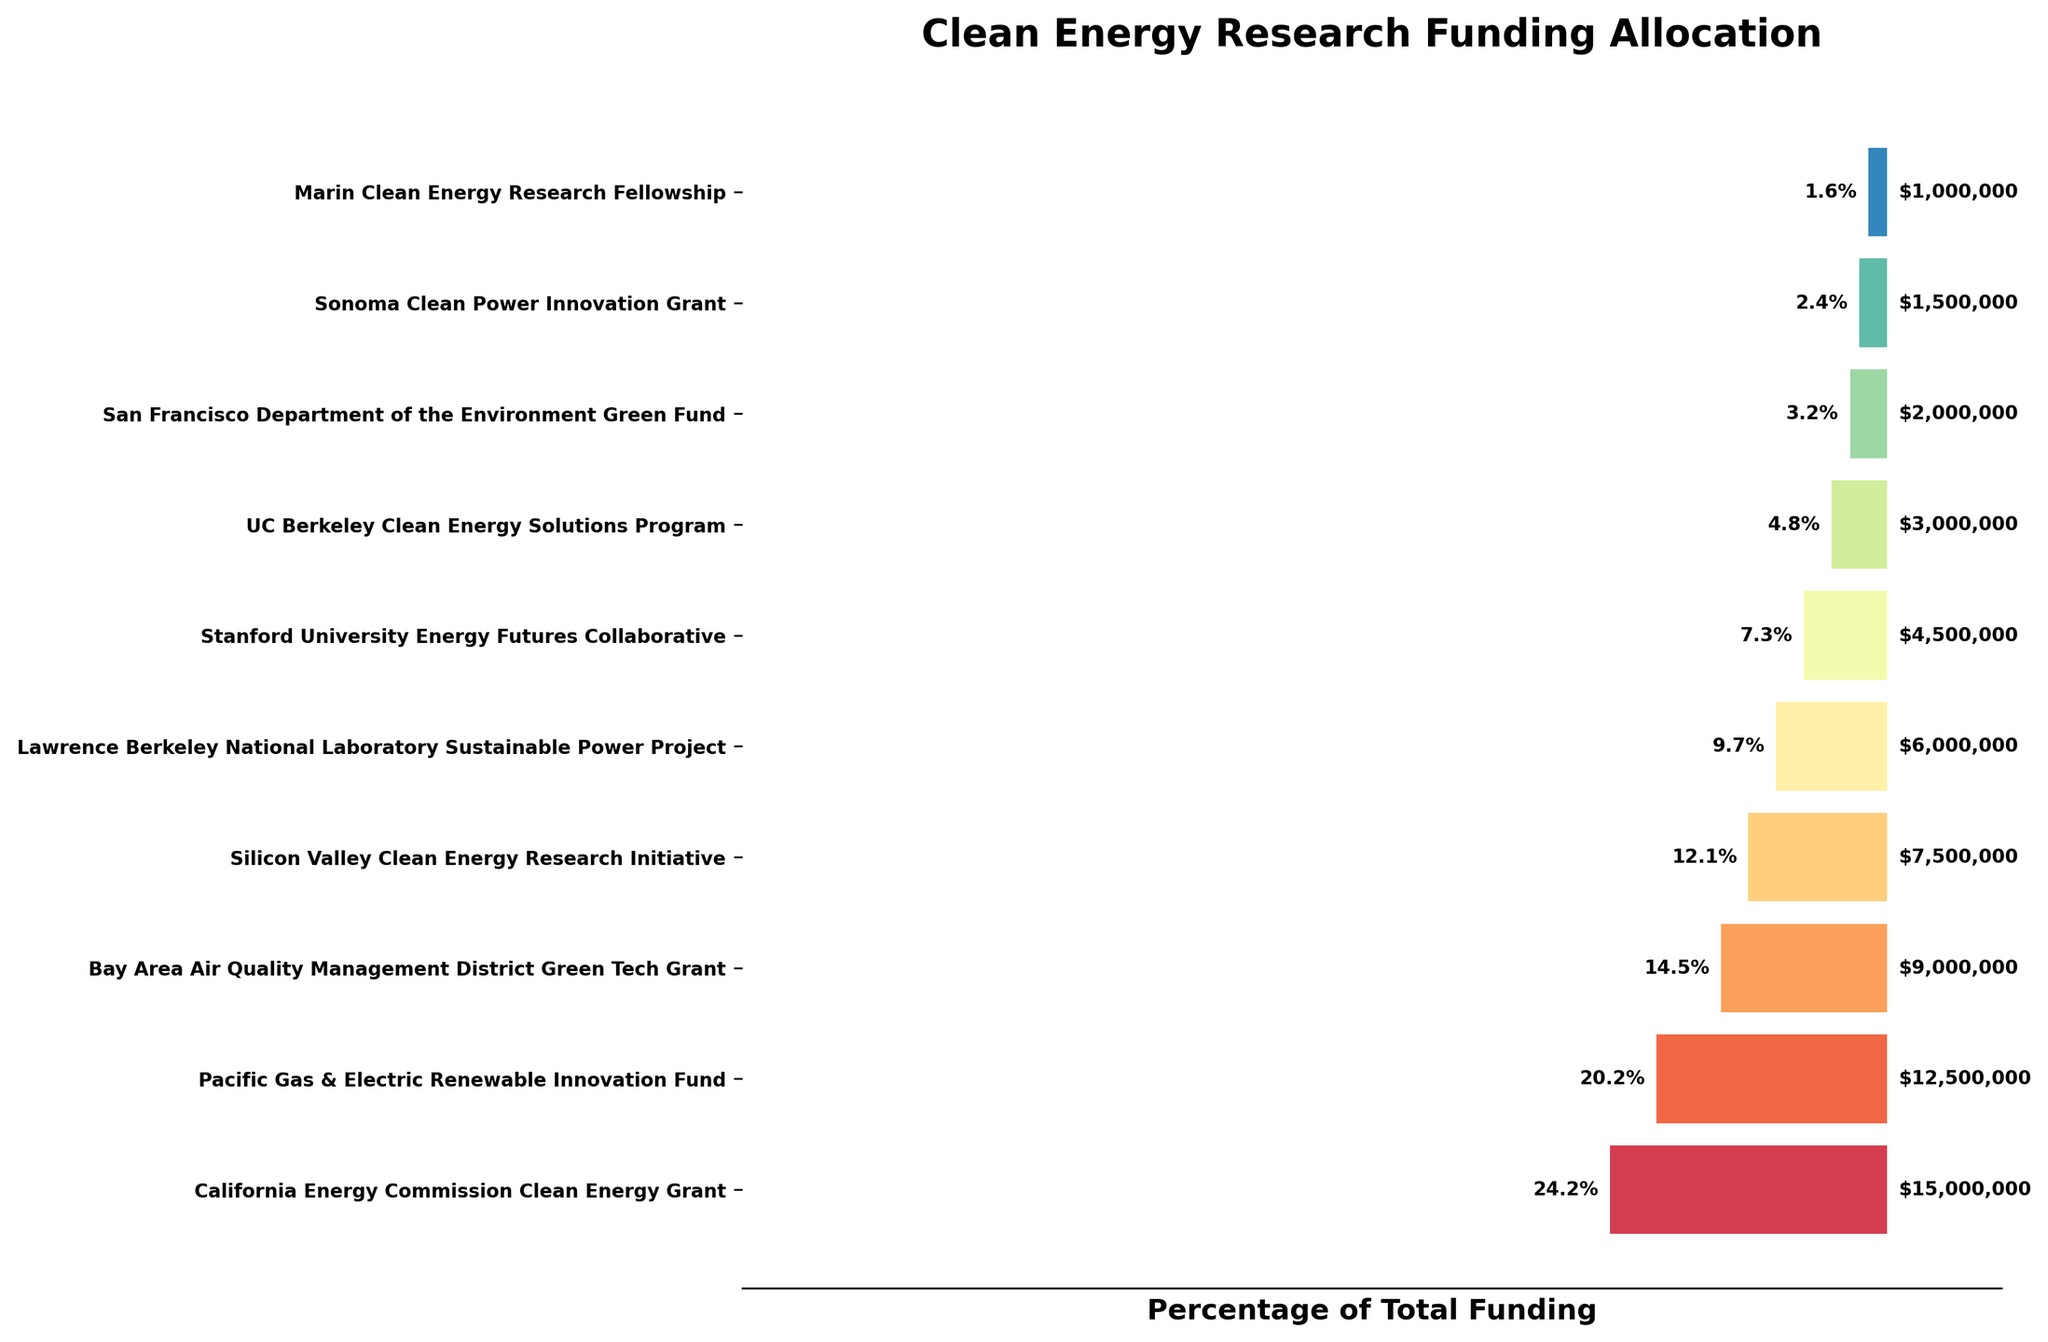How much funding is allocated by the California Energy Commission Clean Energy Grant? The California Energy Commission Clean Energy Grant is listed first in the funnel chart, representing the largest grant. The value displayed next to it is $15,000,000.
Answer: $15,000,000 What is the title of the funnel chart? The title is clearly shown at the top of the funnel chart.
Answer: Clean Energy Research Funding Allocation Which organization received the smallest grant according to the chart? By examining the last segment at the bottom of the funnel chart, the smallest grant is labeled with the Marin Clean Energy Research Fellowship. The value next to it is $1,000,000.
Answer: Marin Clean Energy Research Fellowship What percentage of the total funding is allocated to the Stanford University Energy Futures Collaborative? Locate the Stanford University Energy Futures Collaborative on the funnel chart and find the corresponding percentage next to it. It shows 6.8%.
Answer: 6.8% How many organizations received more than $5,000,000? The funnel chart segments representing more than $5,000,000 grants are for California Energy Commission Clean Energy Grant, Pacific Gas & Electric Renewable Innovation Fund, Bay Area Air Quality Management District Green Tech Grant, Silicon Valley Clean Energy Research Initiative, and Lawrence Berkeley National Laboratory Sustainable Power Project. Counting these up, there are 5 organizations.
Answer: 5 What is the total amount of funding for the bottom three grants combined? Identify the bottom three grants which are San Francisco Department of the Environment Green Fund, Sonoma Clean Power Innovation Grant, and Marin Clean Energy Research Fellowship. Sum their amounts: $2,000,000 + $1,500,000 + $1,000,000 = $4,500,000.
Answer: $4,500,000 How does the funding for the Bay Area Air Quality Management District Green Tech Grant compare to that for the Silicon Valley Clean Energy Research Initiative? Find the amounts for both grants. The Bay Area Air Quality Management District Green Tech Grant received $9,000,000 while the Silicon Valley Clean Energy Research Initiative received $7,500,000. Comparing these values shows that the Bay Area Air Quality Management District Green Tech Grant received more funding.
Answer: Bay Area Air Quality Management District Green Tech Grant received more If the funding from the Pacific Gas & Electric Renewable Innovation Fund and the Lawrence Berkeley National Laboratory Sustainable Power Project were combined, what would their total percentage of the overall funding be? Calculate the combined amount of the two grants: $12,500,000 + $6,000,000 = $18,500,000. Then, find the total funding sum, which is $60,000,000. The combined percentage is ($18,500,000 / $60,000,000) * 100 = 30.8%.
Answer: 30.8% Which grant represents exactly 5% of the total funding? Look for the segment in the funnel chart labeled with a percentage of 5%. The UC Berkeley Clean Energy Solutions Program is the grant that represents 5%.
Answer: UC Berkeley Clean Energy Solutions Program 